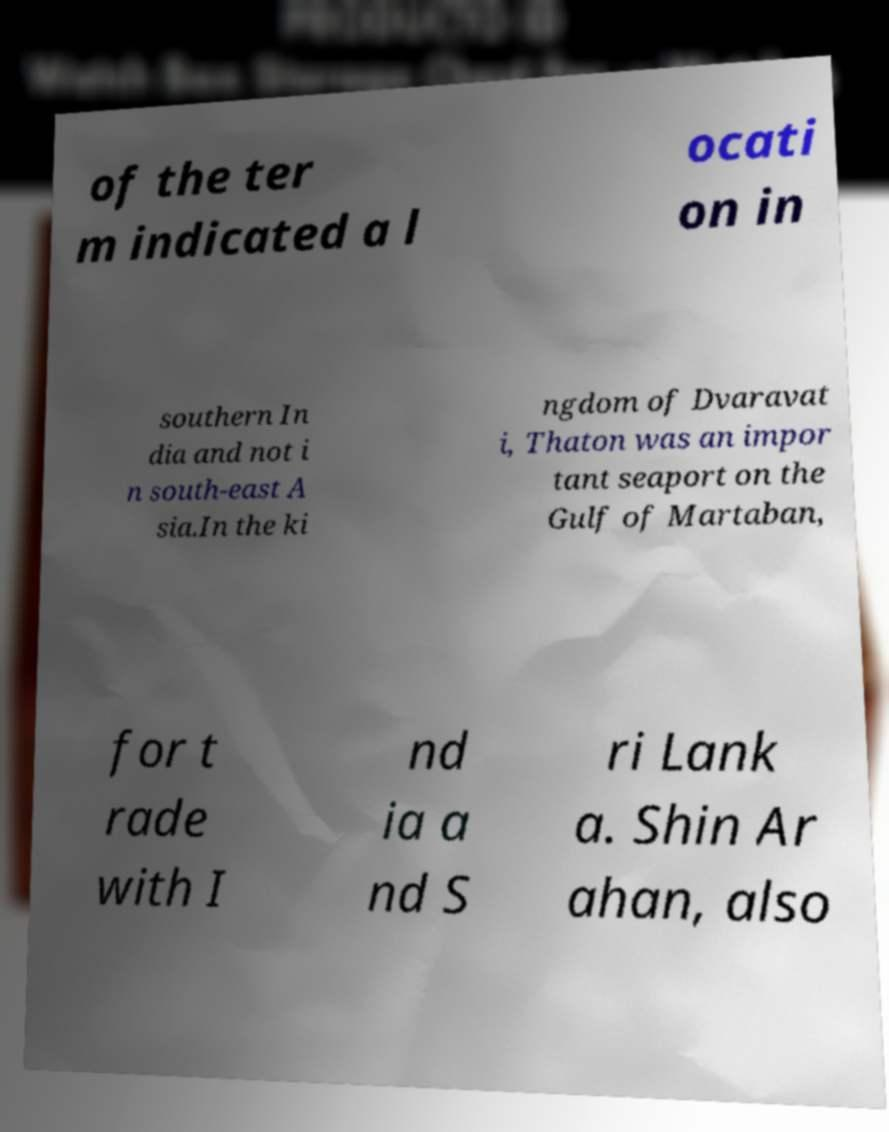Could you assist in decoding the text presented in this image and type it out clearly? of the ter m indicated a l ocati on in southern In dia and not i n south-east A sia.In the ki ngdom of Dvaravat i, Thaton was an impor tant seaport on the Gulf of Martaban, for t rade with I nd ia a nd S ri Lank a. Shin Ar ahan, also 